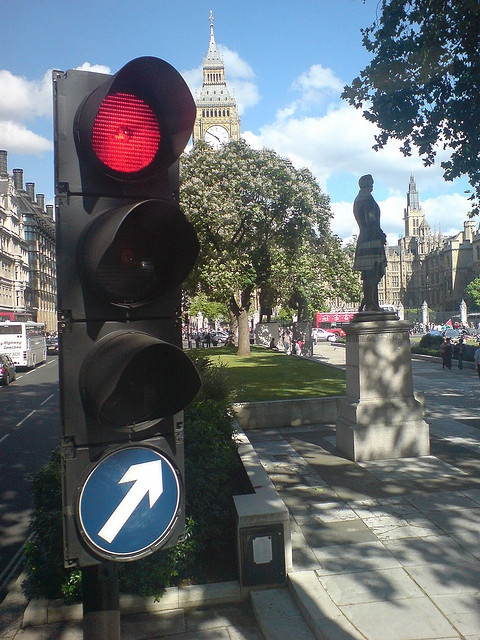Describe the objects in this image and their specific colors. I can see traffic light in gray, black, blue, and white tones, bus in gray, white, and darkgray tones, bus in gray, lightgray, salmon, and lightpink tones, car in gray, black, darkgray, and maroon tones, and people in gray, black, and purple tones in this image. 